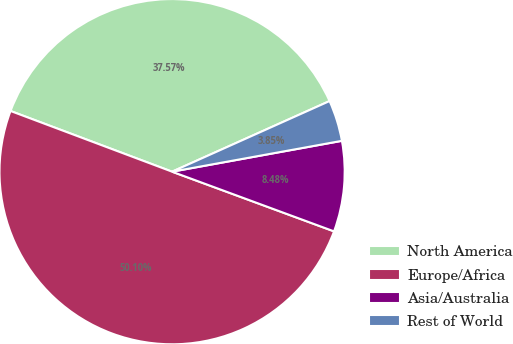Convert chart. <chart><loc_0><loc_0><loc_500><loc_500><pie_chart><fcel>North America<fcel>Europe/Africa<fcel>Asia/Australia<fcel>Rest of World<nl><fcel>37.57%<fcel>50.1%<fcel>8.48%<fcel>3.85%<nl></chart> 